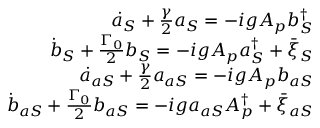Convert formula to latex. <formula><loc_0><loc_0><loc_500><loc_500>\begin{array} { r l r } & { \dot { a } _ { S } + \frac { \gamma } { 2 } a _ { S } = - i g A _ { p } b _ { S } ^ { \dag } } \\ & { \dot { b } _ { S } + \frac { \Gamma _ { 0 } } { 2 } b _ { S } = - i g A _ { p } a _ { S } ^ { \dag } + \bar { \xi } _ { S } } \\ & { \dot { a } _ { a S } + \frac { \gamma } { 2 } a _ { a S } = - i g A _ { p } b _ { a S } } \\ & { \dot { b } _ { a S } + \frac { \Gamma _ { 0 } } { 2 } b _ { a S } = - i g a _ { a S } A _ { p } ^ { \dag } + \bar { \xi } _ { a S } } \end{array}</formula> 